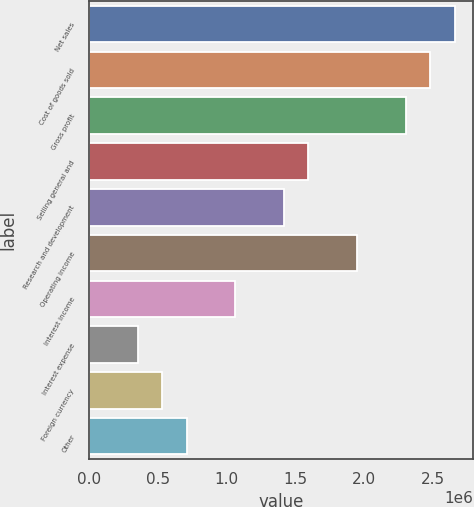<chart> <loc_0><loc_0><loc_500><loc_500><bar_chart><fcel>Net sales<fcel>Cost of goods sold<fcel>Gross profit<fcel>Selling general and<fcel>Research and development<fcel>Operating income<fcel>Interest income<fcel>Interest expense<fcel>Foreign currency<fcel>Other<nl><fcel>2.661e+06<fcel>2.4836e+06<fcel>2.3062e+06<fcel>1.5966e+06<fcel>1.4192e+06<fcel>1.9514e+06<fcel>1.0644e+06<fcel>354802<fcel>532202<fcel>709601<nl></chart> 